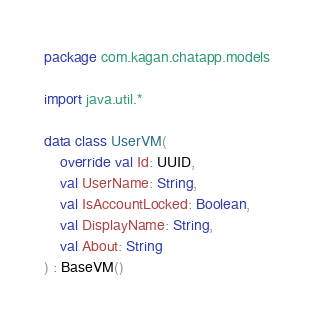<code> <loc_0><loc_0><loc_500><loc_500><_Kotlin_>package com.kagan.chatapp.models

import java.util.*

data class UserVM(
    override val Id: UUID,
    val UserName: String,
    val IsAccountLocked: Boolean,
    val DisplayName: String,
    val About: String
) : BaseVM()</code> 